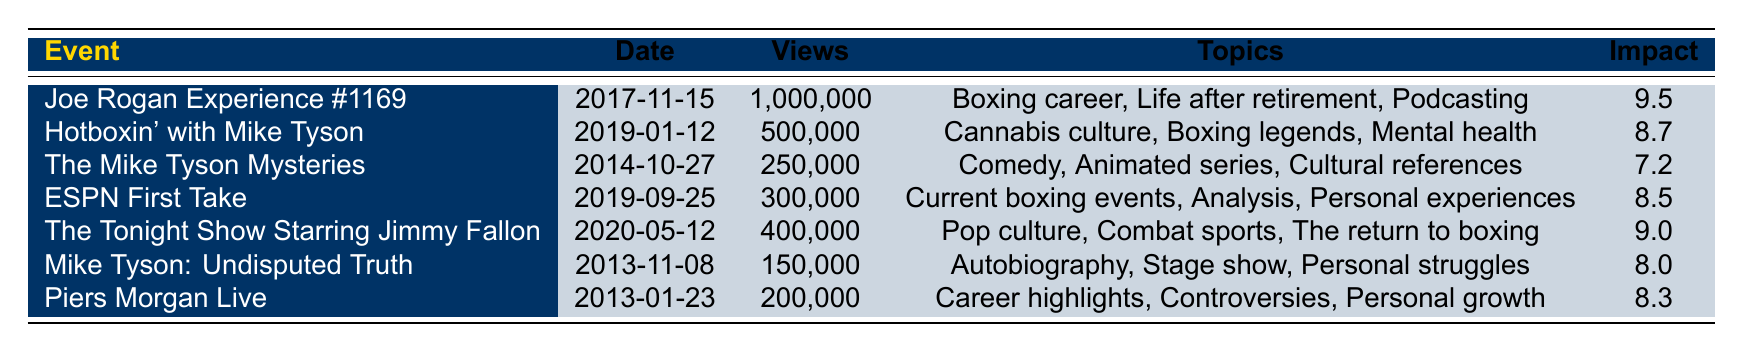What is the event with the highest views? The event with the highest views is "Joe Rogan Experience #1169" with 1,000,000 views. This can be found directly by comparing the views across all events in the table.
Answer: Joe Rogan Experience #1169 Which event has an impact factor of 9.0? The event with an impact factor of 9.0 is "The Tonight Show Starring Jimmy Fallon". This is directly stated in the impact column of the event.
Answer: The Tonight Show Starring Jimmy Fallon What is the total number of views for events that discuss "Boxing career"? Only one event discusses "Boxing career," which is "Joe Rogan Experience #1169" with 1,000,000 views. Since only one event is relevant, the total is simply its view count.
Answer: 1,000,000 How many events have an impact factor greater than 8.5? There are three events with an impact factor greater than 8.5: "Joe Rogan Experience #1169" (9.5), "The Tonight Show Starring Jimmy Fallon" (9.0), and "Hotboxin' with Mike Tyson" (8.7). Count these events to find the answer, which is three.
Answer: 3 Is there any event that discusses both "Cannabis culture" and "Boxing"? Yes, "Hotboxin' with Mike Tyson" discusses "Cannabis culture" and is related to boxing as it features Mike Tyson himself. This is clear from the topics discussed in the event.
Answer: Yes What is the average impact factor of all events listed? To find the average impact factor, sum up all the impact factors: 9.5 + 8.7 + 7.2 + 8.5 + 9.0 + 8.0 + 8.3 = 59.2. There are 7 events, so the average is 59.2 / 7 = 8.457, which rounds to approximately 8.5.
Answer: 8.5 Which event occurred most recently, and what was its view count? The most recent event is "The Tonight Show Starring Jimmy Fallon," which occurred on 2020-05-12, and it has a view count of 400,000. This can be verified by checking the date column for the latest date.
Answer: 400,000 Did "Mike Tyson: Undisputed Truth" have more views than the event with the least views? "Mike Tyson: Undisputed Truth" has 150,000 views, while "The Mike Tyson Mysteries," the event with the least views, has 250,000 views. Consequently, "Mike Tyson: Undisputed Truth" did not have more views.
Answer: No 